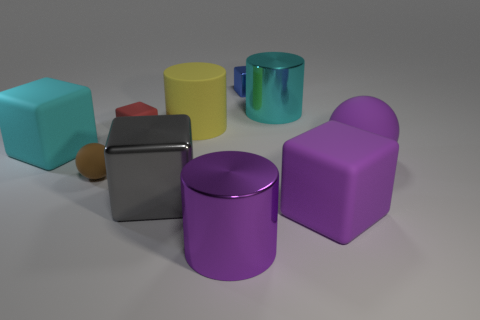Do the shiny thing in front of the purple matte cube and the large ball have the same color?
Provide a succinct answer. Yes. Is the number of large cyan rubber cubes that are to the right of the cyan cube the same as the number of blue metallic objects that are left of the yellow matte cylinder?
Give a very brief answer. Yes. Is there anything else that has the same material as the large cyan cylinder?
Provide a succinct answer. Yes. There is a rubber ball that is to the left of the large yellow rubber thing; what color is it?
Ensure brevity in your answer.  Brown. Is the number of yellow things that are in front of the tiny brown thing the same as the number of yellow rubber cylinders?
Provide a short and direct response. No. How many other things are the same shape as the big yellow object?
Your answer should be very brief. 2. There is a tiny red block; what number of cyan objects are in front of it?
Give a very brief answer. 1. There is a rubber thing that is to the left of the large yellow matte object and in front of the cyan rubber block; what is its size?
Ensure brevity in your answer.  Small. Are any small blue metallic blocks visible?
Provide a short and direct response. Yes. How many other objects are there of the same size as the gray metallic thing?
Provide a succinct answer. 6. 